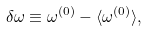Convert formula to latex. <formula><loc_0><loc_0><loc_500><loc_500>\delta \omega \equiv \omega ^ { ( 0 ) } - \langle \omega ^ { ( 0 ) } \rangle ,</formula> 